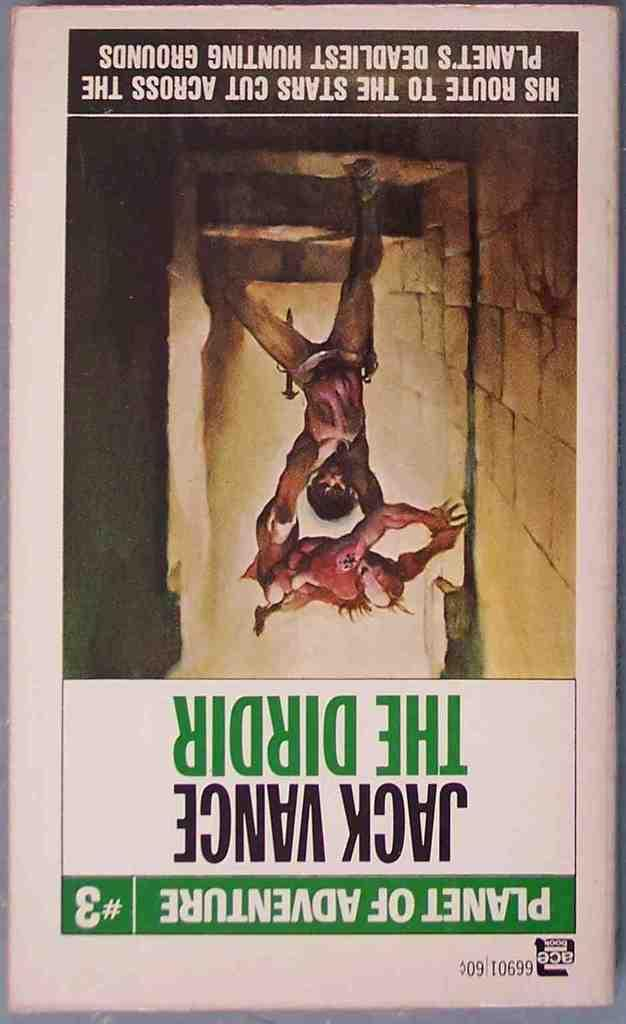Provide a one-sentence caption for the provided image. The book shown in the photot is from the series Planet of Adveture. 